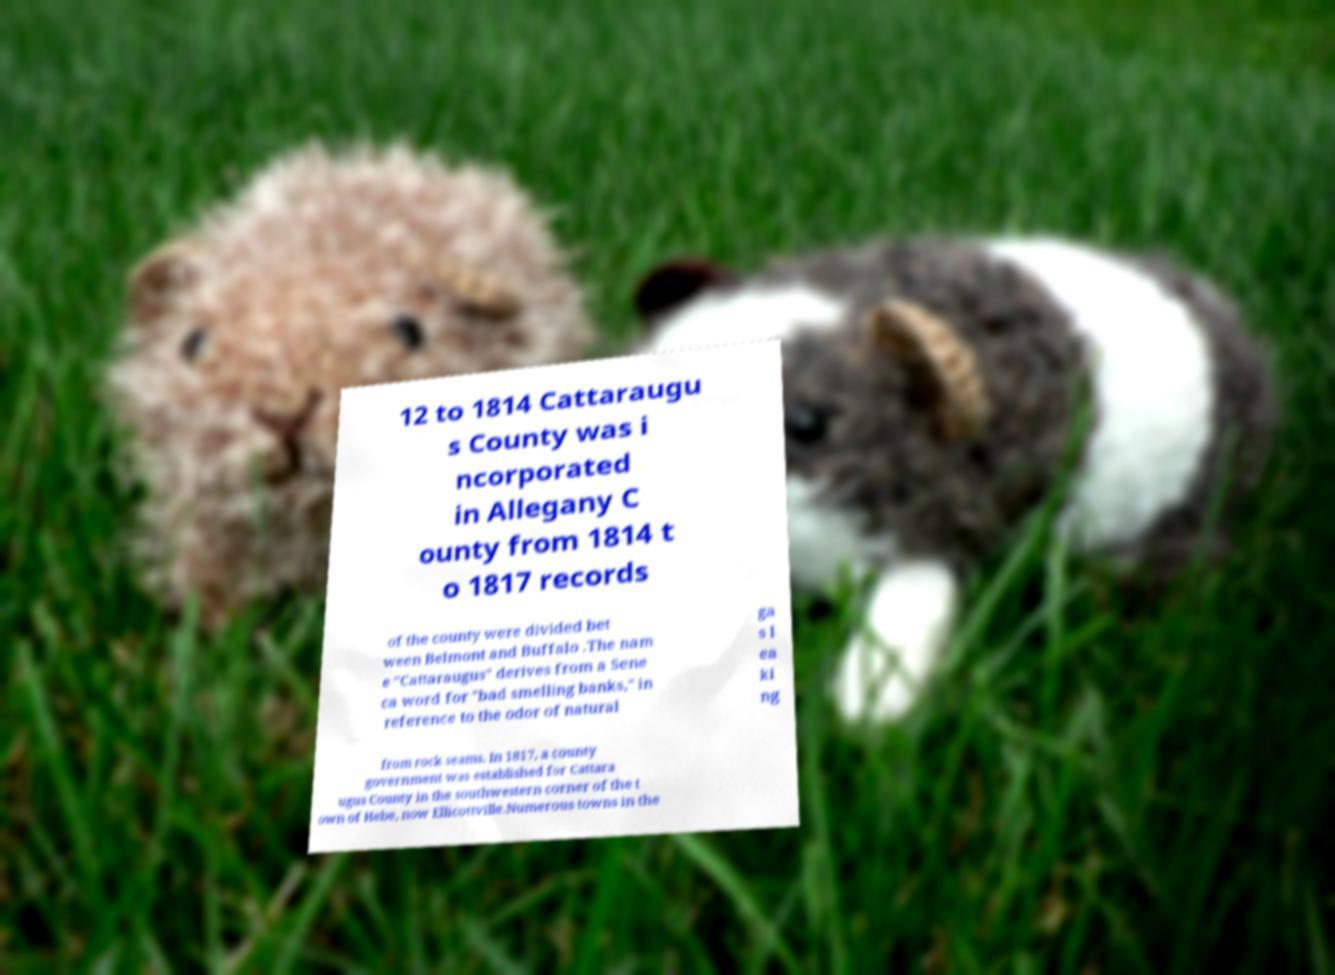Can you accurately transcribe the text from the provided image for me? 12 to 1814 Cattaraugu s County was i ncorporated in Allegany C ounty from 1814 t o 1817 records of the county were divided bet ween Belmont and Buffalo .The nam e "Cattaraugus" derives from a Sene ca word for "bad smelling banks," in reference to the odor of natural ga s l ea ki ng from rock seams. In 1817, a county government was established for Cattara ugus County in the southwestern corner of the t own of Hebe, now Ellicottville.Numerous towns in the 